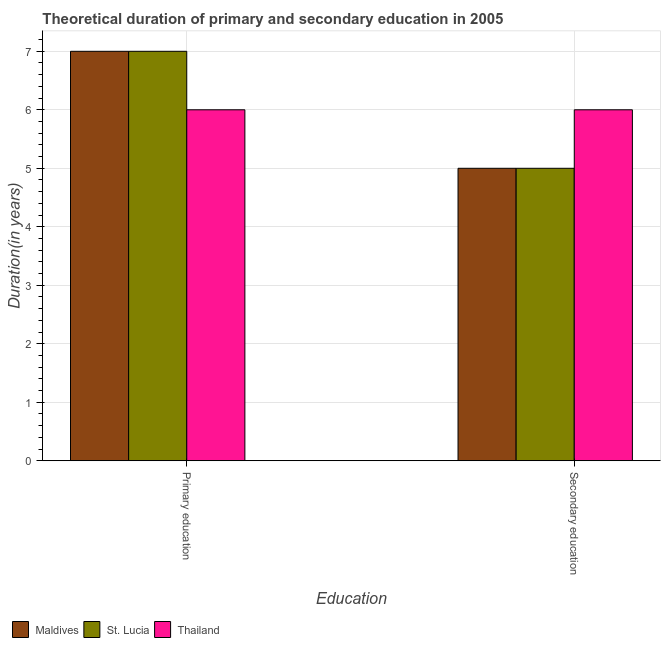How many different coloured bars are there?
Ensure brevity in your answer.  3. Are the number of bars on each tick of the X-axis equal?
Ensure brevity in your answer.  Yes. How many bars are there on the 2nd tick from the right?
Offer a very short reply. 3. What is the label of the 2nd group of bars from the left?
Your answer should be compact. Secondary education. What is the duration of primary education in Maldives?
Offer a very short reply. 7. Across all countries, what is the maximum duration of secondary education?
Provide a short and direct response. 6. Across all countries, what is the minimum duration of secondary education?
Offer a very short reply. 5. In which country was the duration of secondary education maximum?
Make the answer very short. Thailand. In which country was the duration of primary education minimum?
Make the answer very short. Thailand. What is the total duration of secondary education in the graph?
Give a very brief answer. 16. What is the difference between the duration of secondary education in Thailand and that in St. Lucia?
Keep it short and to the point. 1. What is the difference between the duration of secondary education in Maldives and the duration of primary education in St. Lucia?
Give a very brief answer. -2. What is the average duration of secondary education per country?
Your response must be concise. 5.33. What is the difference between the duration of secondary education and duration of primary education in St. Lucia?
Provide a succinct answer. -2. In how many countries, is the duration of secondary education greater than the average duration of secondary education taken over all countries?
Keep it short and to the point. 1. What does the 3rd bar from the left in Primary education represents?
Your answer should be compact. Thailand. What does the 1st bar from the right in Secondary education represents?
Make the answer very short. Thailand. Where does the legend appear in the graph?
Make the answer very short. Bottom left. How are the legend labels stacked?
Ensure brevity in your answer.  Horizontal. What is the title of the graph?
Offer a terse response. Theoretical duration of primary and secondary education in 2005. What is the label or title of the X-axis?
Give a very brief answer. Education. What is the label or title of the Y-axis?
Your response must be concise. Duration(in years). What is the Duration(in years) in Maldives in Primary education?
Offer a terse response. 7. What is the Duration(in years) in St. Lucia in Primary education?
Your response must be concise. 7. What is the Duration(in years) in St. Lucia in Secondary education?
Give a very brief answer. 5. Across all Education, what is the maximum Duration(in years) of St. Lucia?
Keep it short and to the point. 7. Across all Education, what is the maximum Duration(in years) in Thailand?
Ensure brevity in your answer.  6. Across all Education, what is the minimum Duration(in years) in Maldives?
Your answer should be compact. 5. What is the total Duration(in years) of St. Lucia in the graph?
Your answer should be compact. 12. What is the difference between the Duration(in years) in Maldives in Primary education and that in Secondary education?
Provide a succinct answer. 2. What is the difference between the Duration(in years) of St. Lucia in Primary education and that in Secondary education?
Give a very brief answer. 2. What is the difference between the Duration(in years) in Maldives in Primary education and the Duration(in years) in St. Lucia in Secondary education?
Ensure brevity in your answer.  2. What is the average Duration(in years) of Thailand per Education?
Your answer should be very brief. 6. What is the difference between the Duration(in years) in Maldives and Duration(in years) in Thailand in Primary education?
Offer a very short reply. 1. What is the difference between the Duration(in years) of St. Lucia and Duration(in years) of Thailand in Primary education?
Make the answer very short. 1. What is the ratio of the Duration(in years) in Maldives in Primary education to that in Secondary education?
Make the answer very short. 1.4. What is the ratio of the Duration(in years) of St. Lucia in Primary education to that in Secondary education?
Provide a short and direct response. 1.4. What is the ratio of the Duration(in years) of Thailand in Primary education to that in Secondary education?
Ensure brevity in your answer.  1. What is the difference between the highest and the lowest Duration(in years) of Maldives?
Provide a succinct answer. 2. 